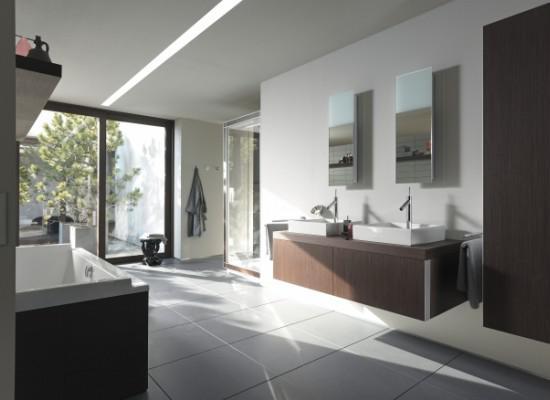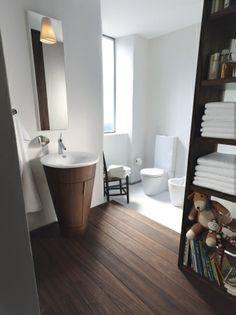The first image is the image on the left, the second image is the image on the right. Assess this claim about the two images: "One of the bathrooms features a shower but no bathtub.". Correct or not? Answer yes or no. No. The first image is the image on the left, the second image is the image on the right. Examine the images to the left and right. Is the description "There is a bide as well as a toilet in a bathroom with at least one shelf behind it" accurate? Answer yes or no. No. 